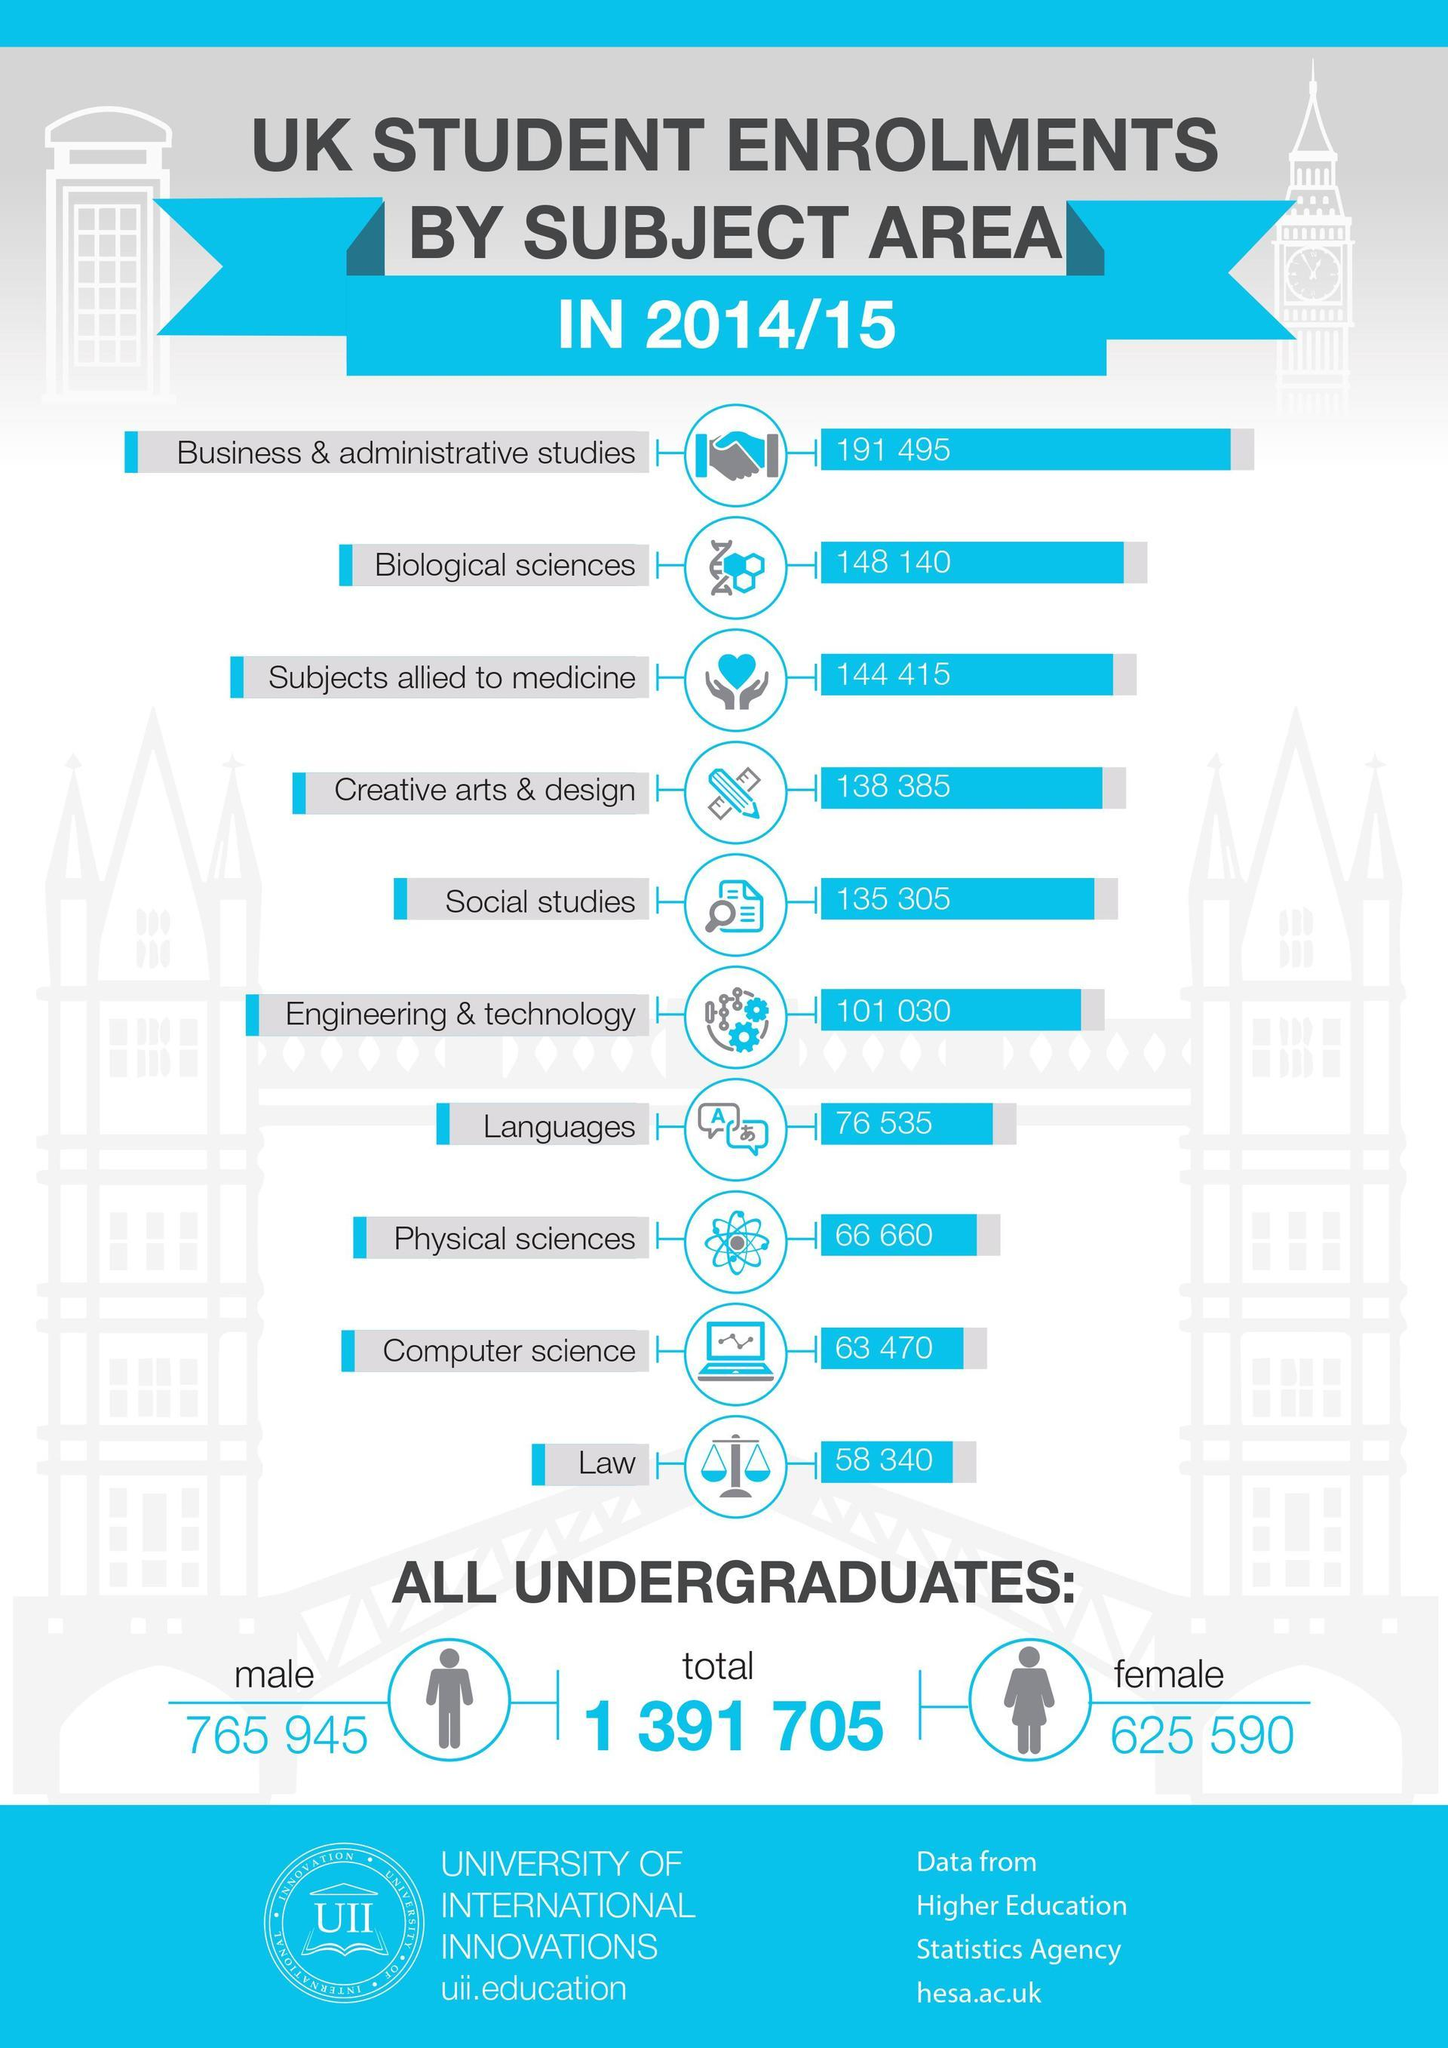Mention a couple of crucial points in this snapshot. There are 625 female undergraduates. Additionally, there are 590 female undergraduates. In total, 292,555 students have enrolled in Biological sciences and subjects allied to medicine. It is clear that Business and Administrative Studies has the highest number of enrolled students among all subjects offered at the institution. 